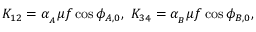Convert formula to latex. <formula><loc_0><loc_0><loc_500><loc_500>K _ { 1 2 } = \alpha _ { _ { A } } \mu f \cos { \phi _ { A , 0 } } , \ K _ { 3 4 } = \alpha _ { _ { B } } \mu f \cos { \phi _ { B , 0 } } ,</formula> 